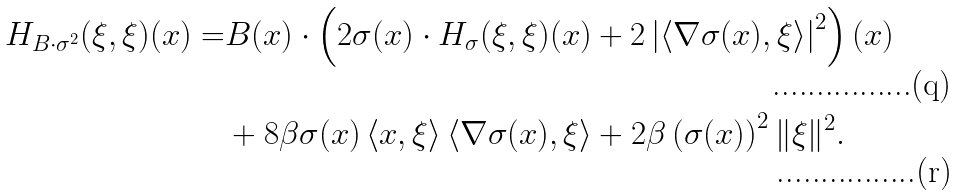<formula> <loc_0><loc_0><loc_500><loc_500>H _ { B \cdot \sigma ^ { 2 } } ( \xi , \xi ) ( x ) = & B ( x ) \cdot \left ( 2 \sigma ( x ) \cdot H _ { \sigma } ( \xi , \xi ) ( x ) + 2 \left | \left \langle \nabla \sigma ( x ) , \xi \right \rangle \right | ^ { 2 } \right ) ( x ) \\ & + 8 \beta \sigma ( x ) \left \langle x , \xi \right \rangle \langle \nabla \sigma ( x ) , \xi \rangle + 2 \beta \left ( \sigma ( x ) \right ) ^ { 2 } \| \xi \| ^ { 2 } .</formula> 